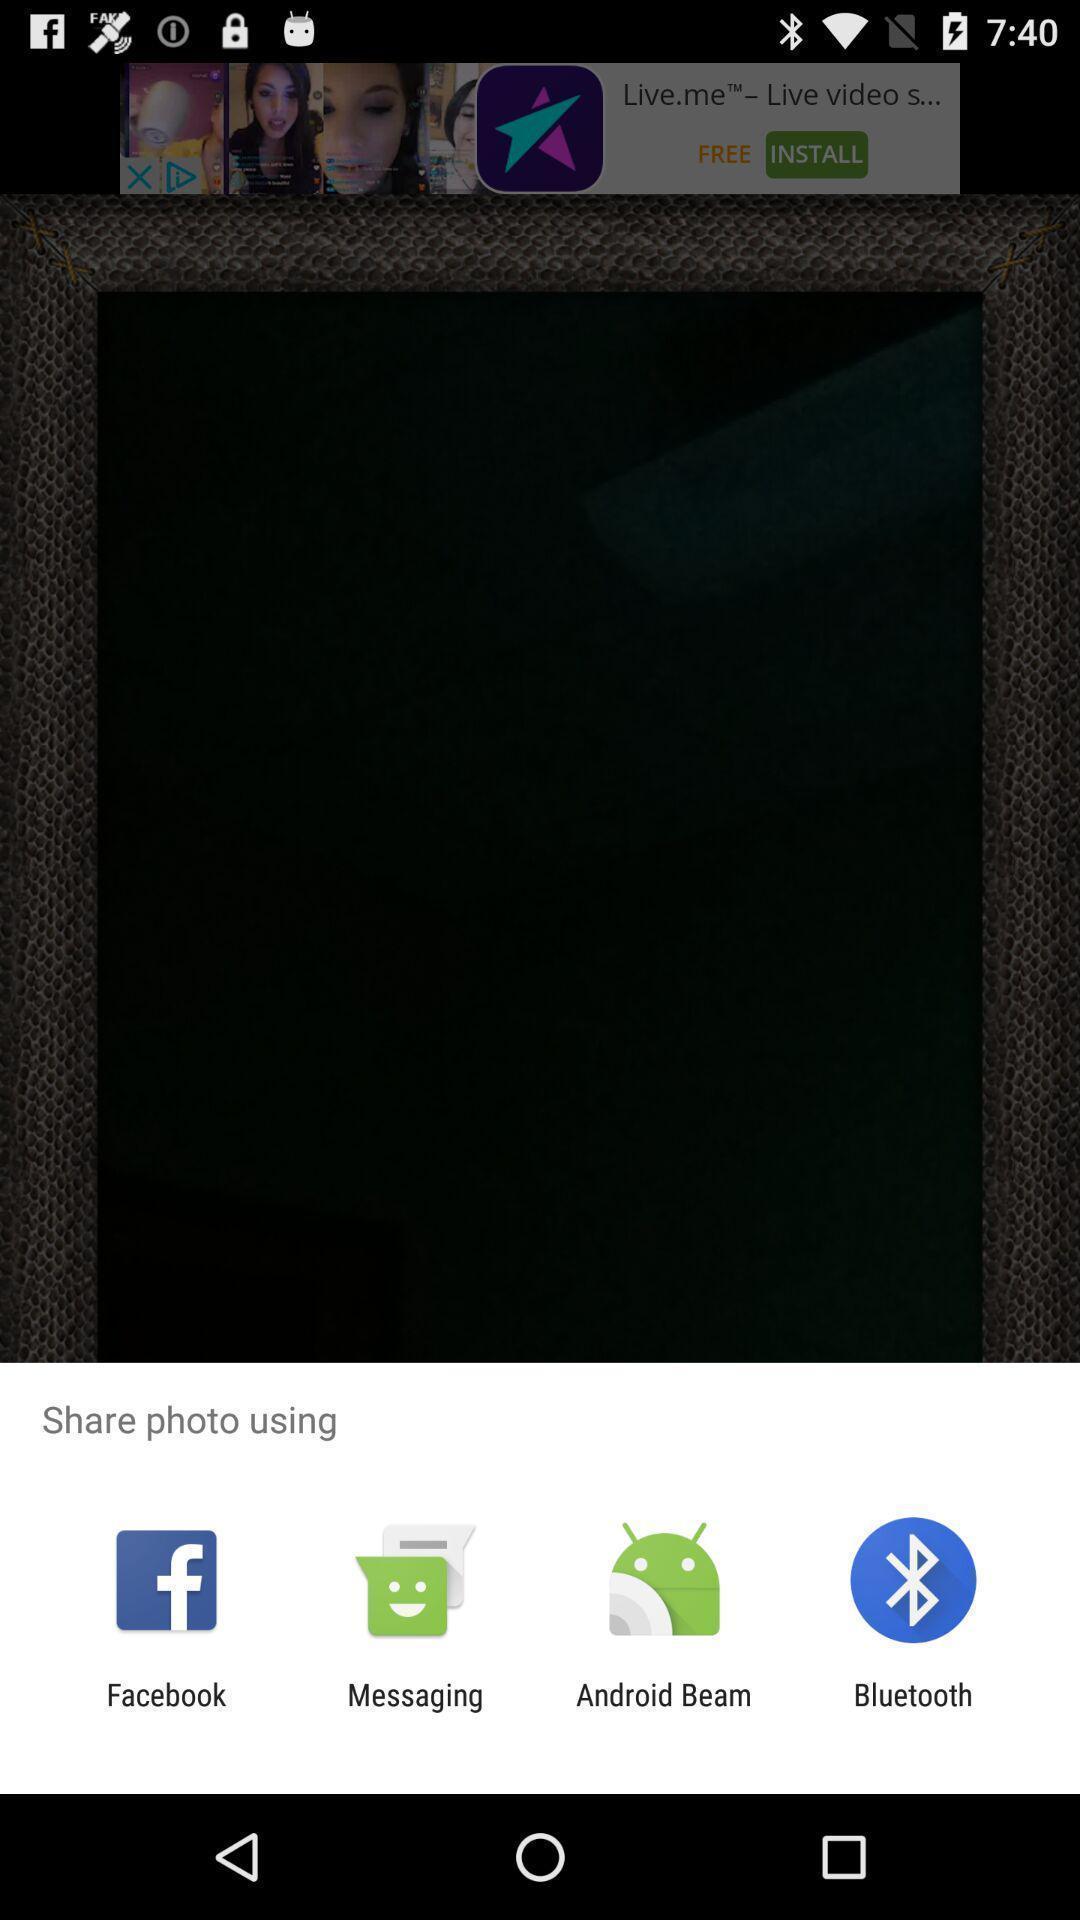Please provide a description for this image. Pop up to share photo through various applications. 